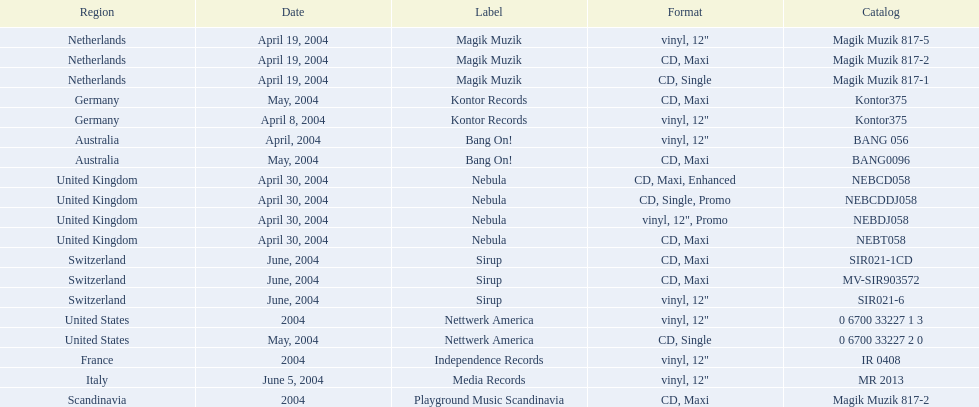What label was italy on? Media Records. 